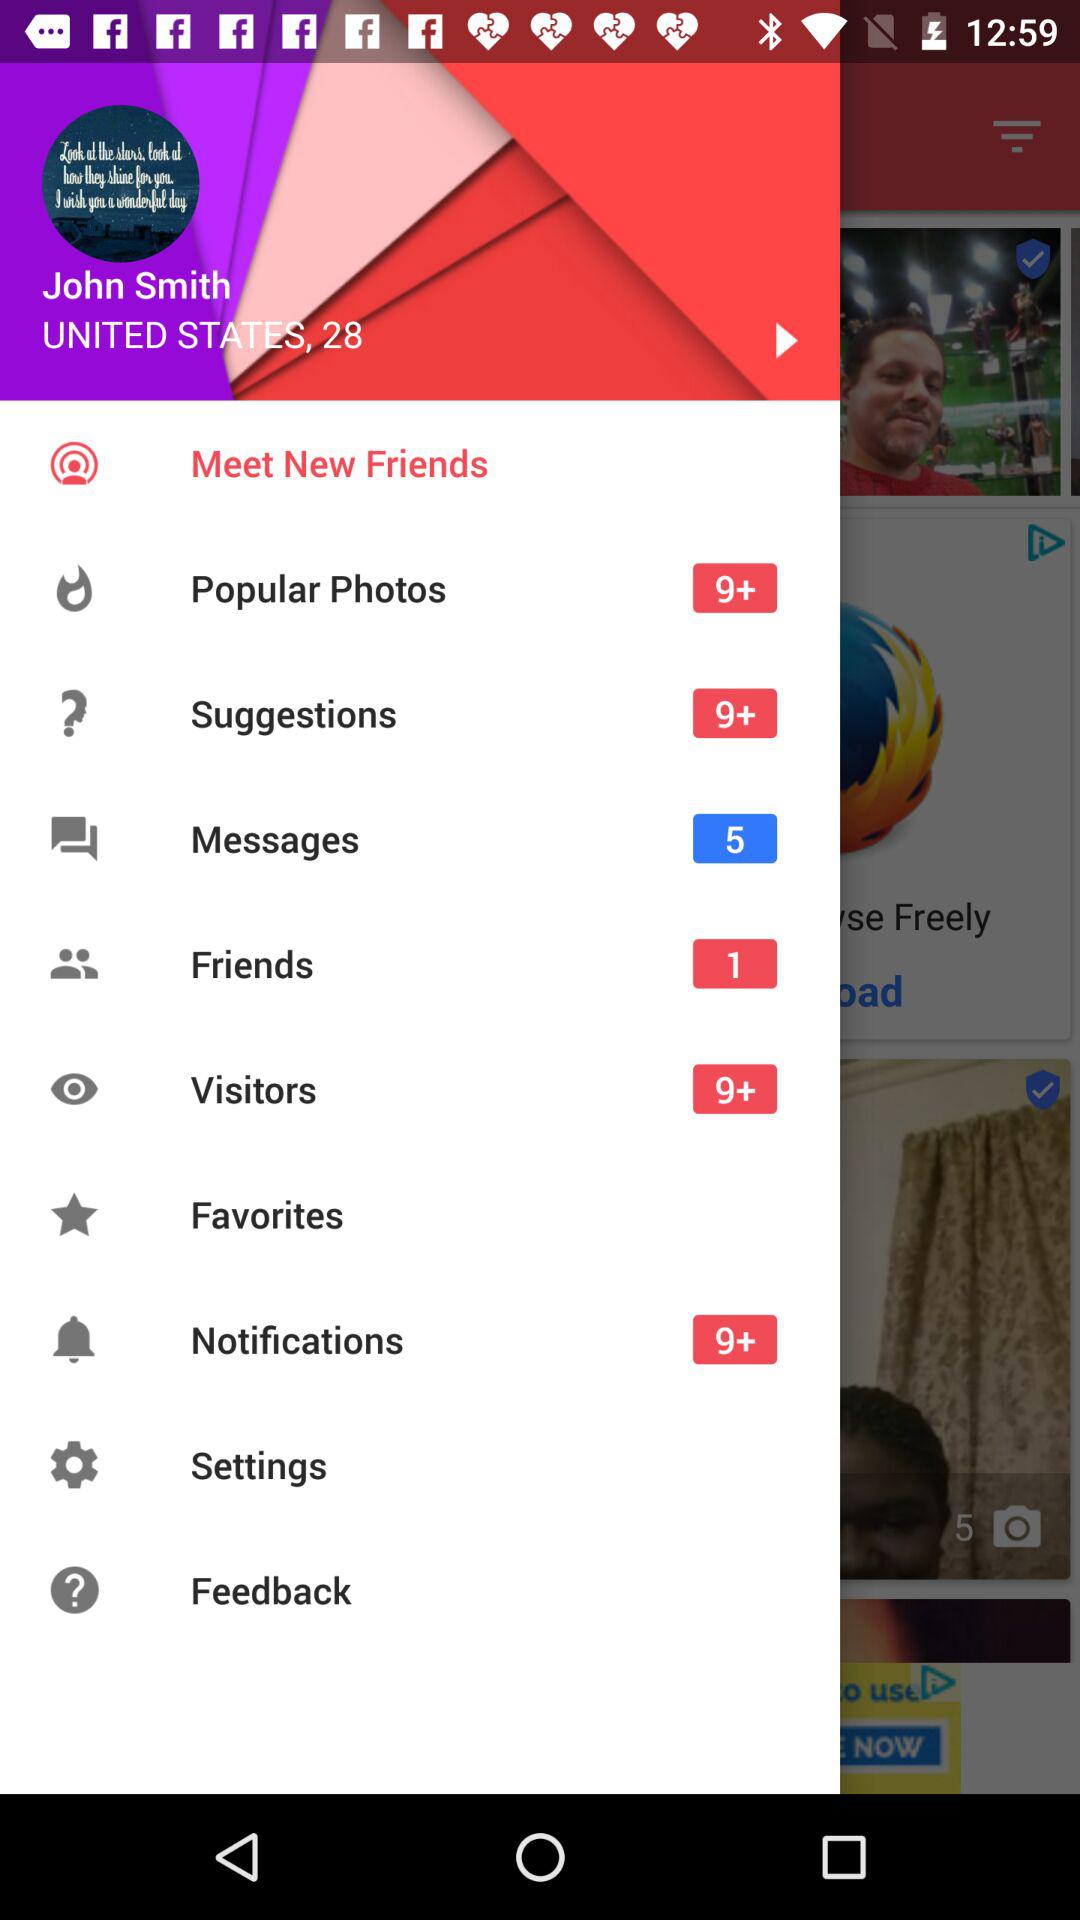Where does John Smith belong? John Smith belongs to the United States. 